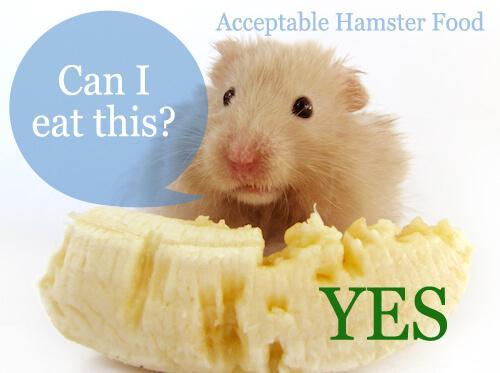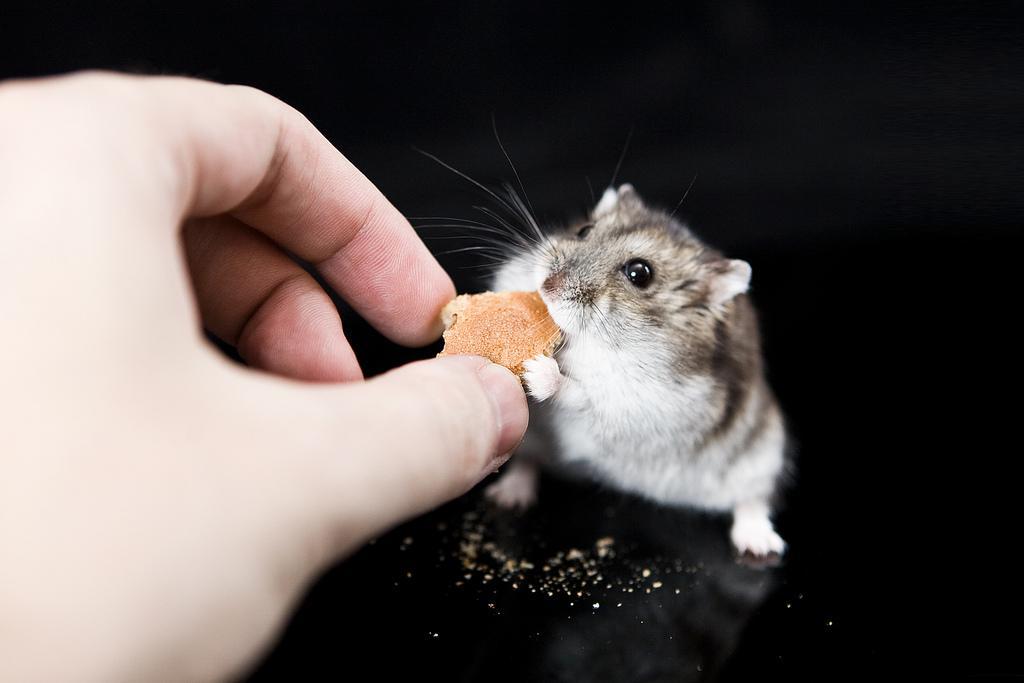The first image is the image on the left, the second image is the image on the right. Evaluate the accuracy of this statement regarding the images: "An image shows an orange-and-white hamster next to a clear bowl of food.". Is it true? Answer yes or no. No. The first image is the image on the left, the second image is the image on the right. Evaluate the accuracy of this statement regarding the images: "A hamster is eating off a clear bowl full of food.". Is it true? Answer yes or no. No. 